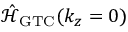<formula> <loc_0><loc_0><loc_500><loc_500>\mathcal { \hat { H } } _ { G T C } ( k _ { z } = 0 )</formula> 